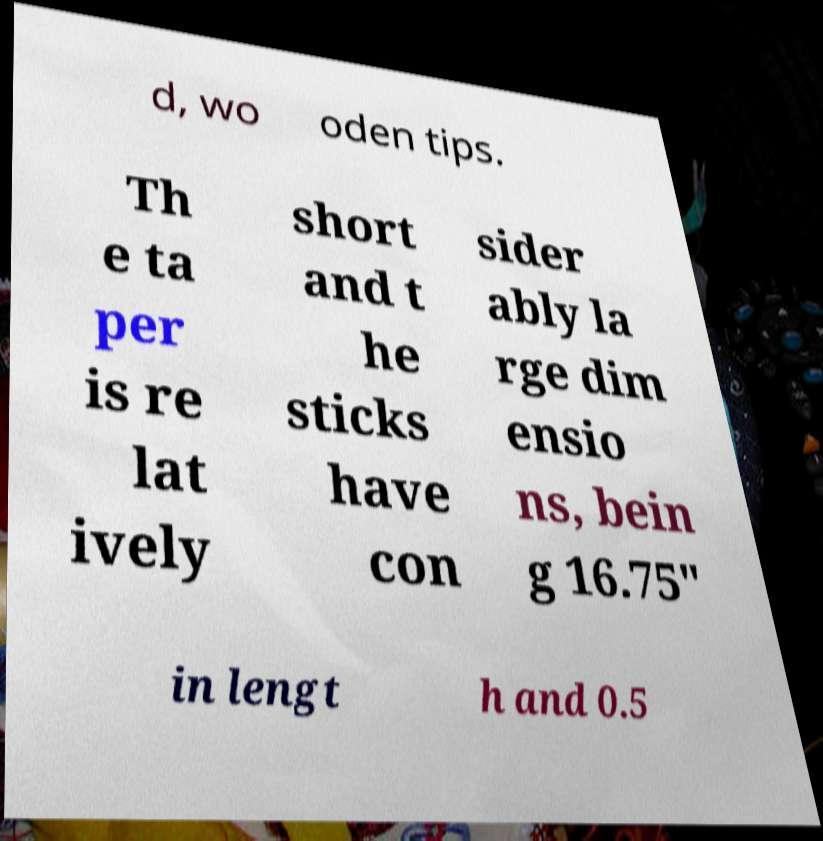Please identify and transcribe the text found in this image. d, wo oden tips. Th e ta per is re lat ively short and t he sticks have con sider ably la rge dim ensio ns, bein g 16.75" in lengt h and 0.5 